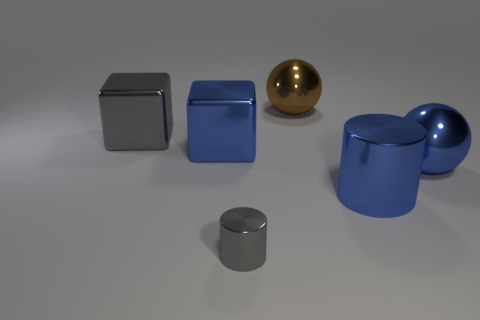What shape is the brown thing that is the same size as the gray block?
Give a very brief answer. Sphere. There is a shiny cylinder left of the brown object; how big is it?
Provide a short and direct response. Small. Is the color of the large metal cube behind the blue block the same as the block that is on the right side of the large gray block?
Your answer should be very brief. No. What is the material of the sphere right of the big ball behind the big blue object on the right side of the large blue cylinder?
Offer a very short reply. Metal. Is there a blue metallic thing of the same size as the blue metal cylinder?
Ensure brevity in your answer.  Yes. There is a blue ball that is the same size as the brown object; what is it made of?
Your answer should be compact. Metal. What is the shape of the blue shiny object on the left side of the gray metallic cylinder?
Give a very brief answer. Cube. Does the gray thing on the right side of the big gray object have the same material as the large blue ball that is right of the brown metal object?
Your answer should be compact. Yes. How many big things are the same shape as the small gray thing?
Provide a succinct answer. 1. There is a cube that is the same color as the tiny shiny cylinder; what material is it?
Offer a terse response. Metal. 